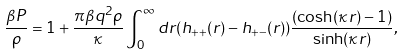Convert formula to latex. <formula><loc_0><loc_0><loc_500><loc_500>\frac { \beta P } { \rho } = 1 + \frac { \pi \beta q ^ { 2 } \rho } { \kappa } \int _ { 0 } ^ { \infty } d r ( h _ { + + } ( r ) - h _ { + - } ( r ) ) \frac { ( \cosh ( \kappa r ) - 1 ) } { \sinh ( \kappa r ) } ,</formula> 